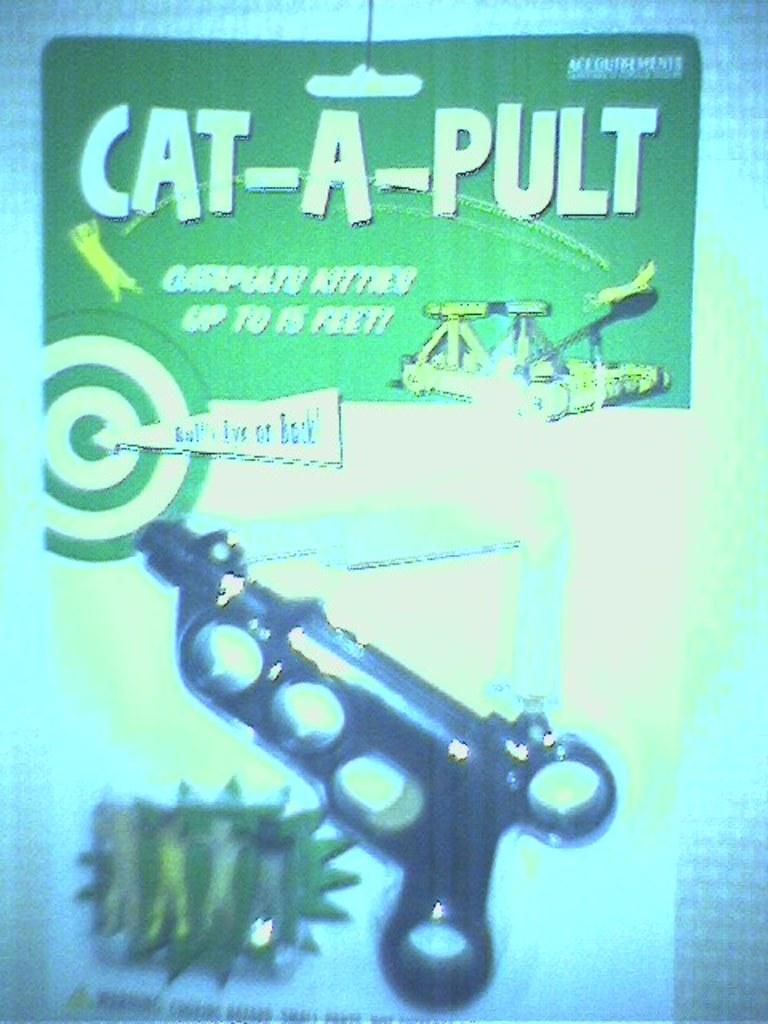What is the name of this item?
Give a very brief answer. Cat-a-pult. How many feet does it shoot?
Keep it short and to the point. 15. 